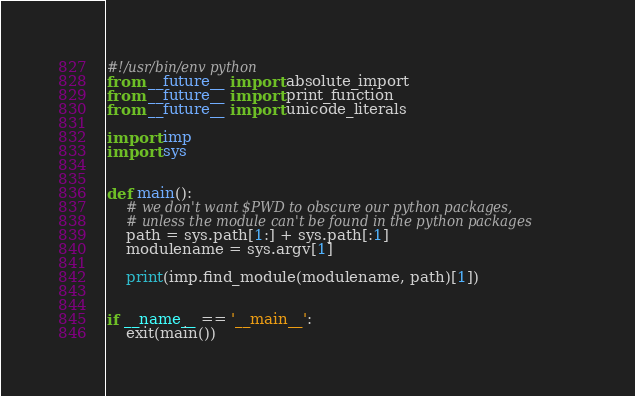Convert code to text. <code><loc_0><loc_0><loc_500><loc_500><_Python_>#!/usr/bin/env python
from __future__ import absolute_import
from __future__ import print_function
from __future__ import unicode_literals

import imp
import sys


def main():
    # we don't want $PWD to obscure our python packages,
    # unless the module can't be found in the python packages
    path = sys.path[1:] + sys.path[:1]
    modulename = sys.argv[1]

    print(imp.find_module(modulename, path)[1])


if __name__ == '__main__':
    exit(main())
</code> 